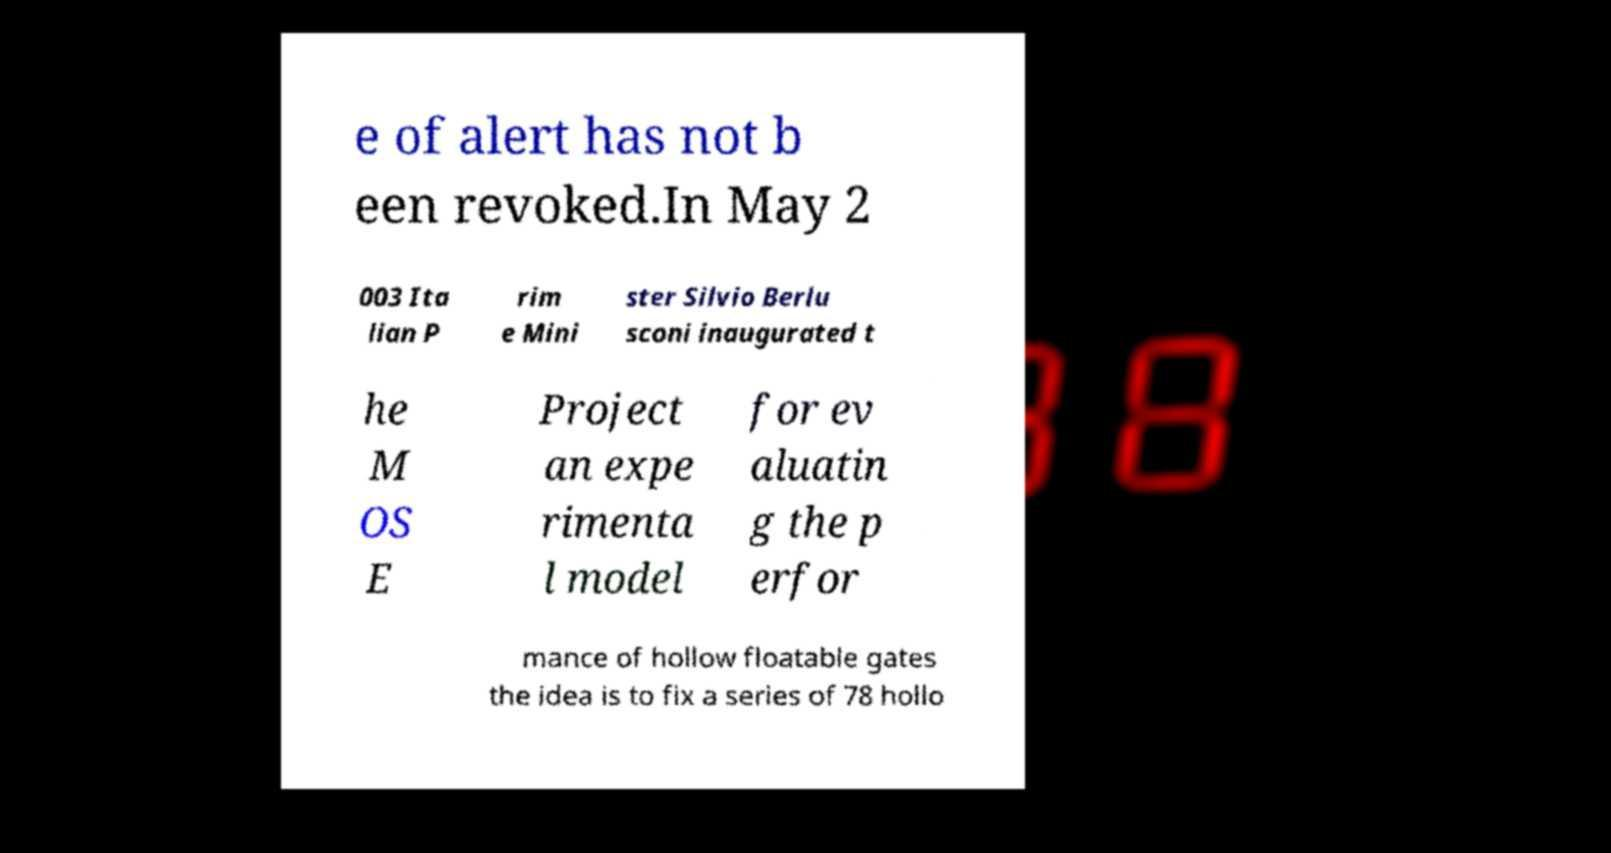Can you accurately transcribe the text from the provided image for me? e of alert has not b een revoked.In May 2 003 Ita lian P rim e Mini ster Silvio Berlu sconi inaugurated t he M OS E Project an expe rimenta l model for ev aluatin g the p erfor mance of hollow floatable gates the idea is to fix a series of 78 hollo 